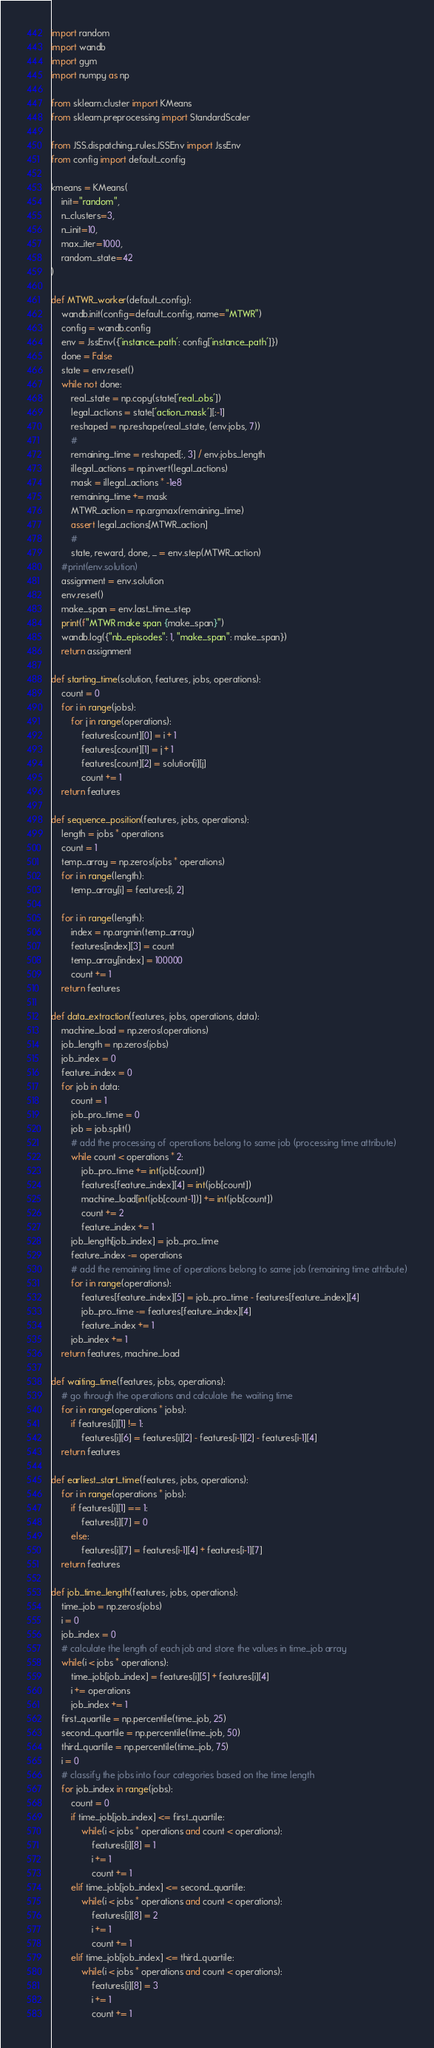Convert code to text. <code><loc_0><loc_0><loc_500><loc_500><_Python_>import random
import wandb
import gym
import numpy as np

from sklearn.cluster import KMeans
from sklearn.preprocessing import StandardScaler

from JSS.dispatching_rules.JSSEnv import JssEnv
from config import default_config

kmeans = KMeans(
    init="random",
    n_clusters=3,
    n_init=10,
    max_iter=1000,
    random_state=42
)

def MTWR_worker(default_config):
    wandb.init(config=default_config, name="MTWR")
    config = wandb.config
    env = JssEnv({'instance_path': config['instance_path']})
    done = False
    state = env.reset()
    while not done:
        real_state = np.copy(state['real_obs'])
        legal_actions = state['action_mask'][:-1]
        reshaped = np.reshape(real_state, (env.jobs, 7))
        #
        remaining_time = reshaped[:, 3] / env.jobs_length
        illegal_actions = np.invert(legal_actions)
        mask = illegal_actions * -1e8
        remaining_time += mask
        MTWR_action = np.argmax(remaining_time)
        assert legal_actions[MTWR_action]
        #
        state, reward, done, _ = env.step(MTWR_action)
    #print(env.solution)
    assignment = env.solution
    env.reset()
    make_span = env.last_time_step
    print(f"MTWR make span {make_span}")
    wandb.log({"nb_episodes": 1, "make_span": make_span})
    return assignment

def starting_time(solution, features, jobs, operations):
    count = 0
    for i in range(jobs):
        for j in range(operations):
            features[count][0] = i + 1
            features[count][1] = j + 1
            features[count][2] = solution[i][j]
            count += 1
    return features

def sequence_position(features, jobs, operations):
    length = jobs * operations
    count = 1
    temp_array = np.zeros(jobs * operations)
    for i in range(length):
        temp_array[i] = features[i, 2]

    for i in range(length):
        index = np.argmin(temp_array)
        features[index][3] = count
        temp_array[index] = 100000
        count += 1
    return features

def data_extraction(features, jobs, operations, data):
    machine_load = np.zeros(operations)
    job_length = np.zeros(jobs)
    job_index = 0
    feature_index = 0
    for job in data:
        count = 1
        job_pro_time = 0
        job = job.split()
        # add the processing of operations belong to same job (processing time attribute)
        while count < operations * 2:
            job_pro_time += int(job[count])
            features[feature_index][4] = int(job[count])
            machine_load[int(job[count-1])] += int(job[count])
            count += 2
            feature_index += 1
        job_length[job_index] = job_pro_time
        feature_index -= operations
        # add the remaining time of operations belong to same job (remaining time attribute)
        for i in range(operations):
            features[feature_index][5] = job_pro_time - features[feature_index][4]
            job_pro_time -= features[feature_index][4]
            feature_index += 1
        job_index += 1
    return features, machine_load

def waiting_time(features, jobs, operations):
    # go through the operations and calculate the waiting time
    for i in range(operations * jobs):
        if features[i][1] != 1:
            features[i][6] = features[i][2] - features[i-1][2] - features[i-1][4]
    return features

def earliest_start_time(features, jobs, operations):
    for i in range(operations * jobs):
        if features[i][1] == 1:
            features[i][7] = 0
        else:
            features[i][7] = features[i-1][4] + features[i-1][7]
    return features

def job_time_length(features, jobs, operations):
    time_job = np.zeros(jobs)
    i = 0
    job_index = 0
    # calculate the length of each job and store the values in time_job array
    while(i < jobs * operations):
        time_job[job_index] = features[i][5] + features[i][4]
        i += operations
        job_index += 1
    first_quartile = np.percentile(time_job, 25)
    second_quartile = np.percentile(time_job, 50)
    third_quartile = np.percentile(time_job, 75)
    i = 0
    # classify the jobs into four categories based on the time length
    for job_index in range(jobs):
        count = 0
        if time_job[job_index] <= first_quartile:
            while(i < jobs * operations and count < operations):
                features[i][8] = 1
                i += 1
                count += 1
        elif time_job[job_index] <= second_quartile:
            while(i < jobs * operations and count < operations):
                features[i][8] = 2
                i += 1
                count += 1
        elif time_job[job_index] <= third_quartile:
            while(i < jobs * operations and count < operations):
                features[i][8] = 3
                i += 1
                count += 1</code> 